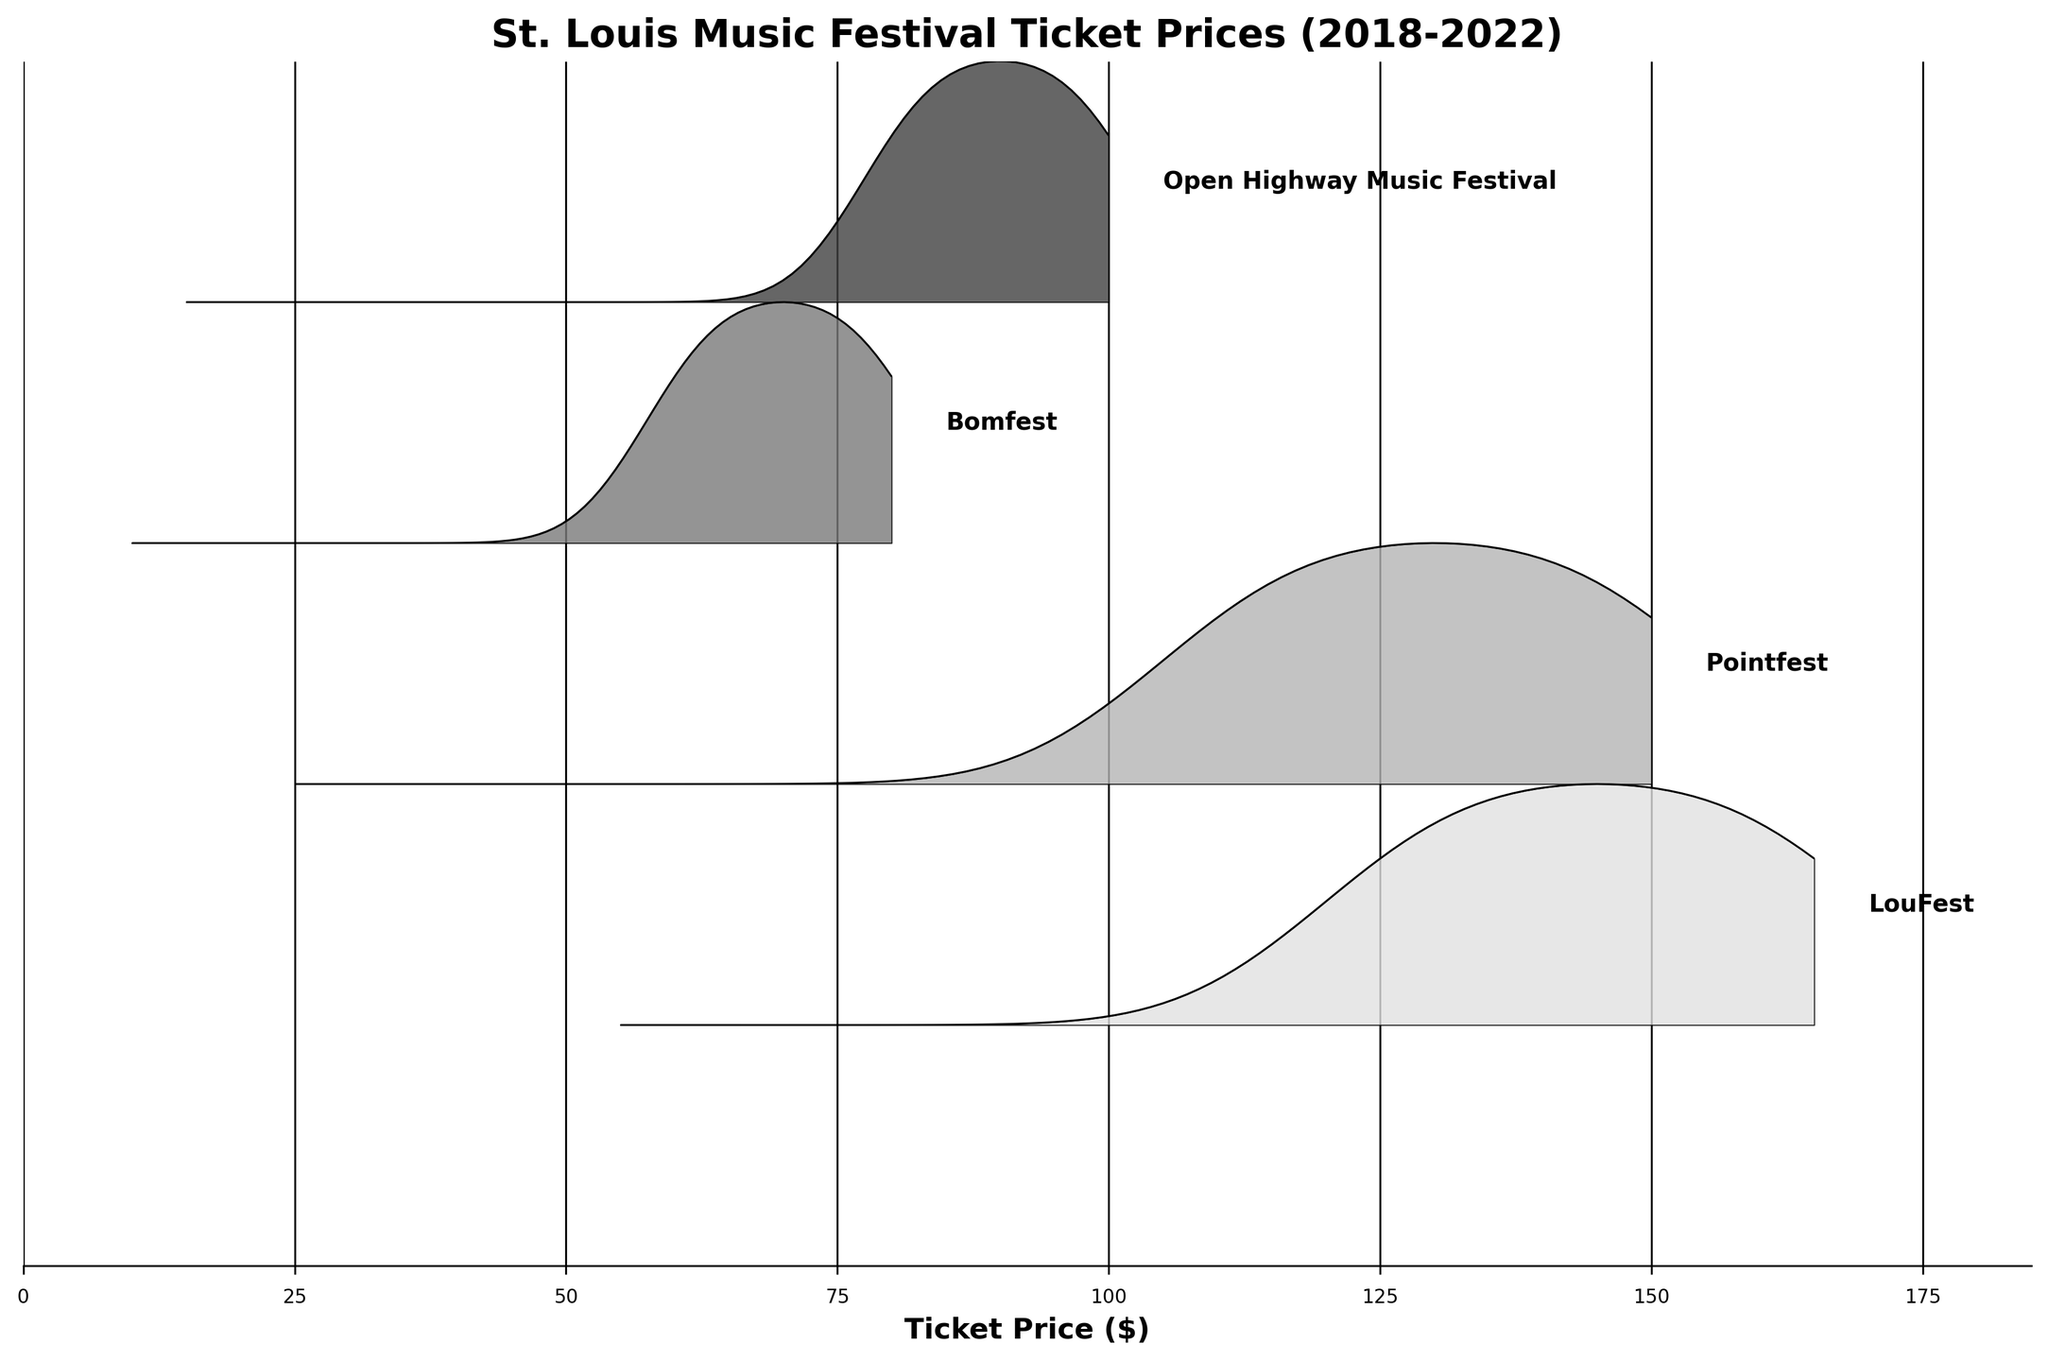what is the range of ticket prices for Pointfest in 2022? The range of ticket prices is specified on the x-axis for each festival and the year is indicated in the plot area. Pointfest in 2022 is displayed with prices ranging from $45 to $150.
Answer: $45-$150 Which festival had the lowest maximum ticket price in 2018? Look for the festival with the lowest peak in 2018 on the x-axis. Bomfest in 2018 has the lowest maximum ticket price of $60.
Answer: Bomfest How do the ticket prices for Open Highway Music Festival in 2022 compare to those in 2018? Compare the positions of the ridgeline plots for Open Highway Music Festival in 2022 and 2018. In 2022, the prices range from $35 to $100, and in 2018, they range from $15 to $80. Hence, prices have increased over the years.
Answer: Increased What is the trend of maximum ticket prices for LouFest over the years 2014 to 2018? Observing the ridgeline plot positions from 2014 to 2018 for LouFest, we can see that the maximum ticket prices have been increasing progressively.
Answer: Increasing Which festival displayed the most stable ticket price range across the years shown? Stability in ticket prices can be inferred from how close the years' ridgeline plots are to each other. Bomfest displays the most stable range, moving consistently upwards in small increments.
Answer: Bomfest 